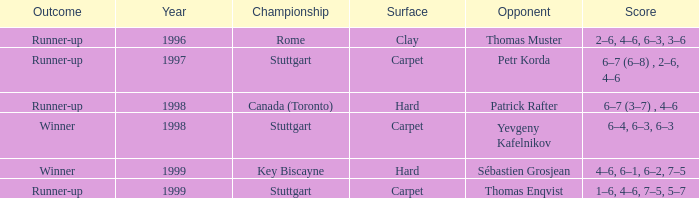How many years did the rival petr korda have? 1.0. 